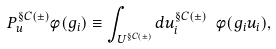Convert formula to latex. <formula><loc_0><loc_0><loc_500><loc_500>P ^ { \S C ( \pm ) } _ { u } \phi ( g _ { i } ) \equiv \int _ { U ^ { \S C ( \pm ) } } d u ^ { \S C ( \pm ) } _ { i } \ { \phi } ( g _ { i } u _ { i } ) ,</formula> 